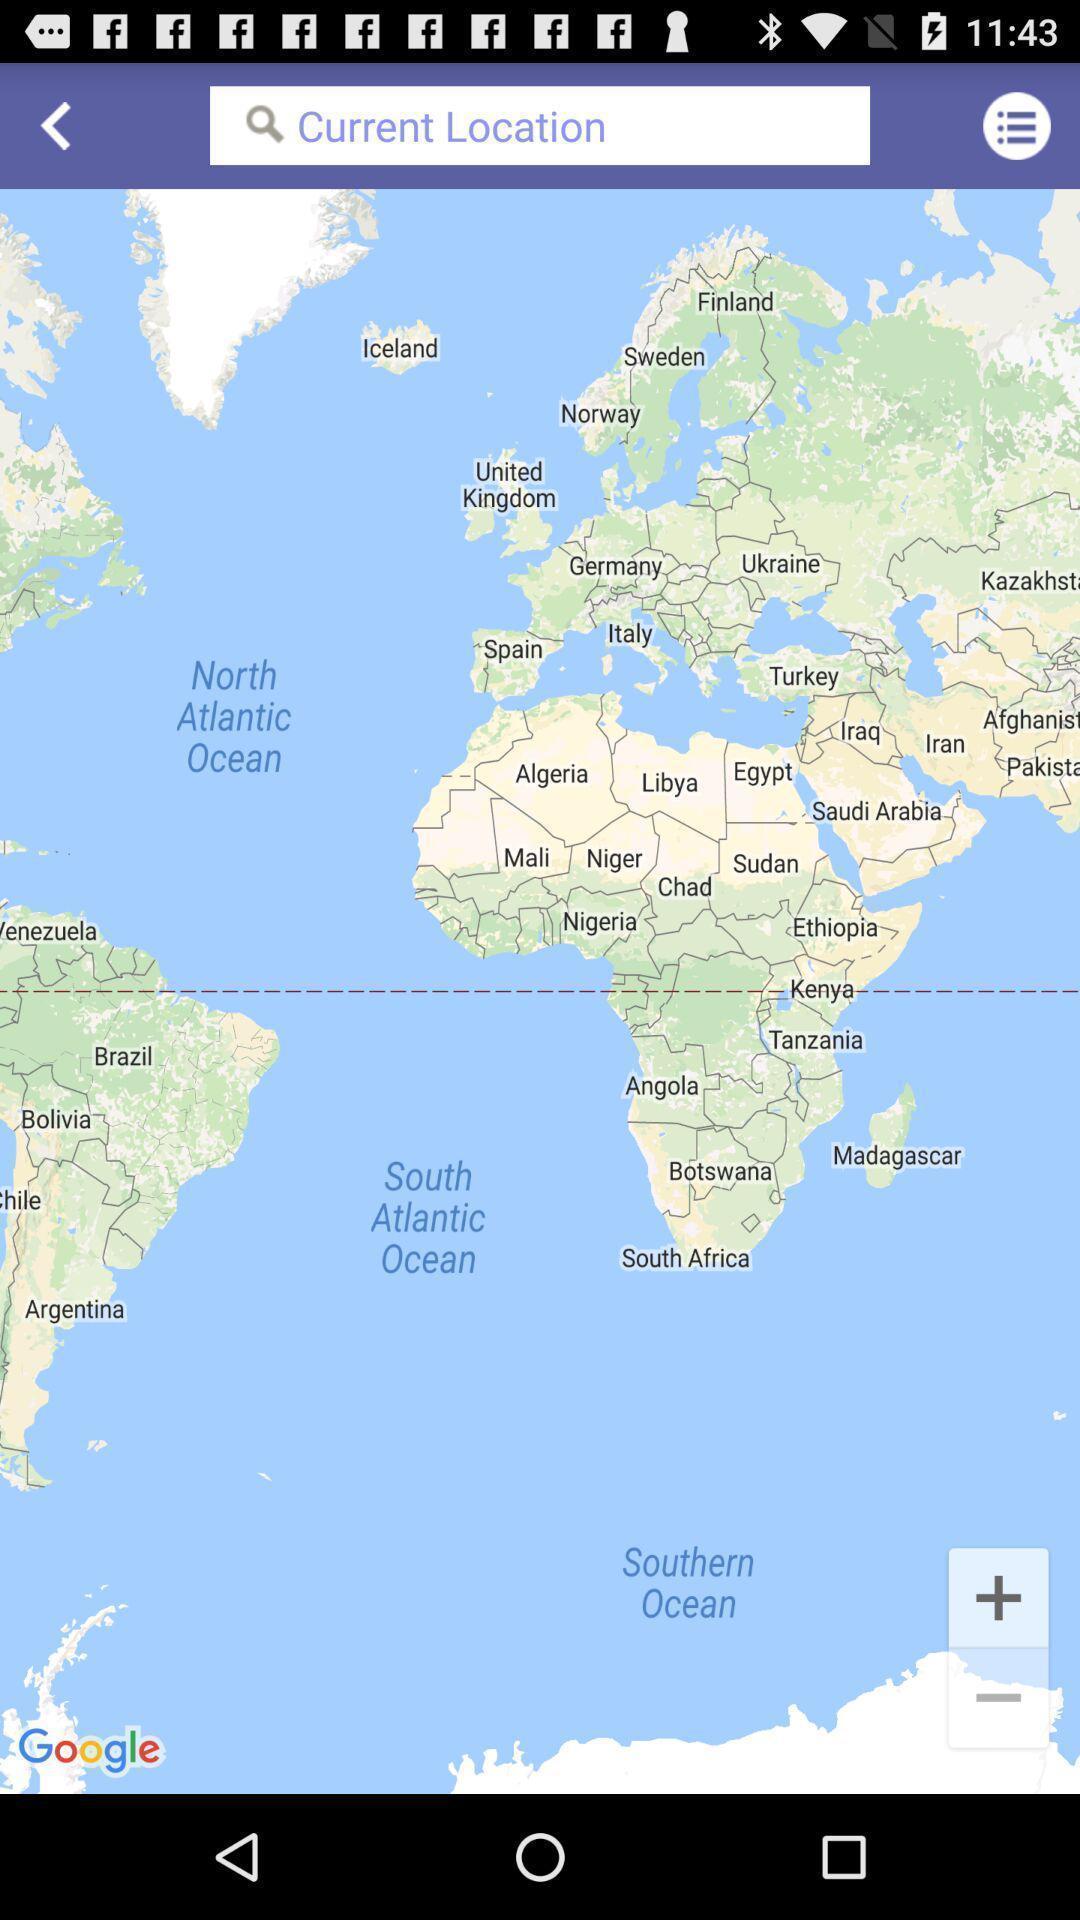Summarize the information in this screenshot. Search page for searching a location. 